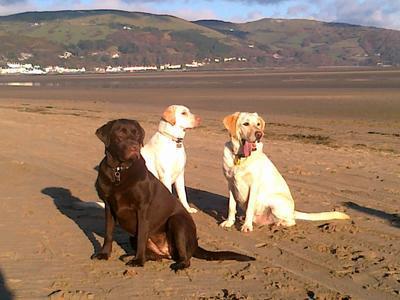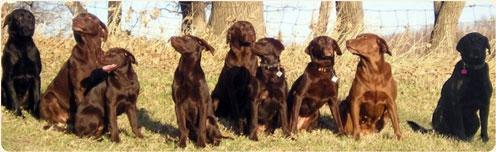The first image is the image on the left, the second image is the image on the right. Given the left and right images, does the statement "Some of the dogs are in the water, and only one dog near the water is not """"blond""""." hold true? Answer yes or no. No. The first image is the image on the left, the second image is the image on the right. Given the left and right images, does the statement "The dogs in the image on the right are near the water." hold true? Answer yes or no. No. 